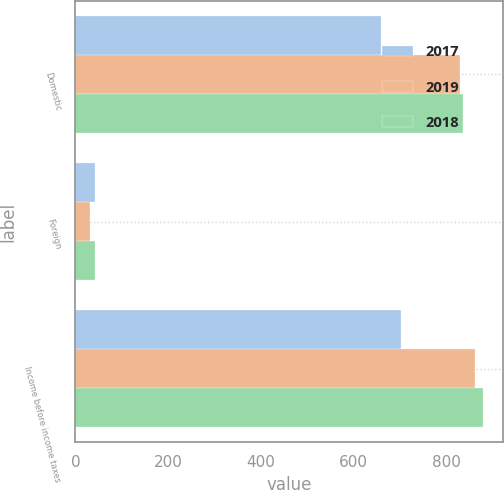Convert chart. <chart><loc_0><loc_0><loc_500><loc_500><stacked_bar_chart><ecel><fcel>Domestic<fcel>Foreign<fcel>Income before income taxes<nl><fcel>2017<fcel>659.2<fcel>42.4<fcel>701.6<nl><fcel>2019<fcel>828.6<fcel>32.4<fcel>861<nl><fcel>2018<fcel>836.8<fcel>41.6<fcel>878.4<nl></chart> 